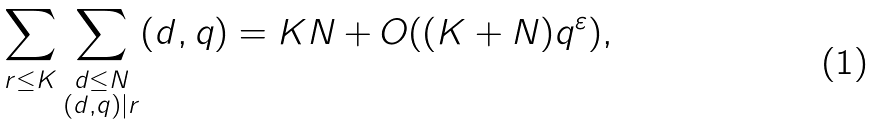Convert formula to latex. <formula><loc_0><loc_0><loc_500><loc_500>\sum _ { r \leq K } \sum _ { \substack { d \leq N \\ ( d , q ) | r } } ( d , q ) = K N + O ( ( K + N ) q ^ { \varepsilon } ) ,</formula> 